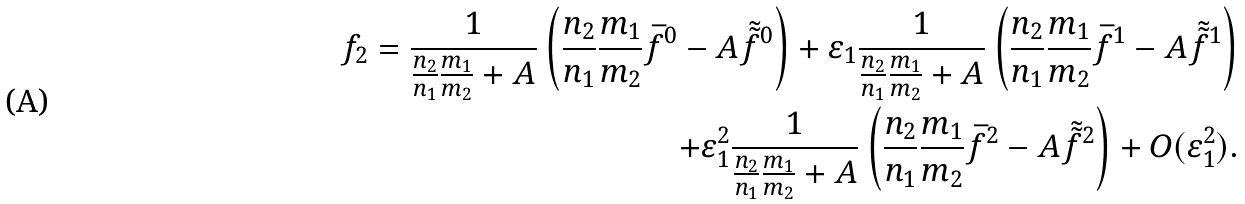Convert formula to latex. <formula><loc_0><loc_0><loc_500><loc_500>f _ { 2 } = \frac { 1 } { \frac { n _ { 2 } } { n _ { 1 } } \frac { m _ { 1 } } { m _ { 2 } } + A } \left ( \frac { n _ { 2 } } { n _ { 1 } } \frac { m _ { 1 } } { m _ { 2 } } \bar { f } ^ { 0 } - A \tilde { \tilde { f } } ^ { 0 } \right ) + \varepsilon _ { 1 } \frac { 1 } { \frac { n _ { 2 } } { n _ { 1 } } \frac { m _ { 1 } } { m _ { 2 } } + A } \left ( \frac { n _ { 2 } } { n _ { 1 } } \frac { m _ { 1 } } { m _ { 2 } } \bar { f } ^ { 1 } - A \tilde { \tilde { f } } ^ { 1 } \right ) \\ + \varepsilon ^ { 2 } _ { 1 } \frac { 1 } { \frac { n _ { 2 } } { n _ { 1 } } \frac { m _ { 1 } } { m _ { 2 } } + A } \left ( \frac { n _ { 2 } } { n _ { 1 } } \frac { m _ { 1 } } { m _ { 2 } } \bar { f } ^ { 2 } - A \tilde { \tilde { f } } ^ { 2 } \right ) + O ( \varepsilon _ { 1 } ^ { 2 } ) .</formula> 